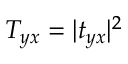Convert formula to latex. <formula><loc_0><loc_0><loc_500><loc_500>T _ { y x } = | t _ { y x } | ^ { 2 }</formula> 